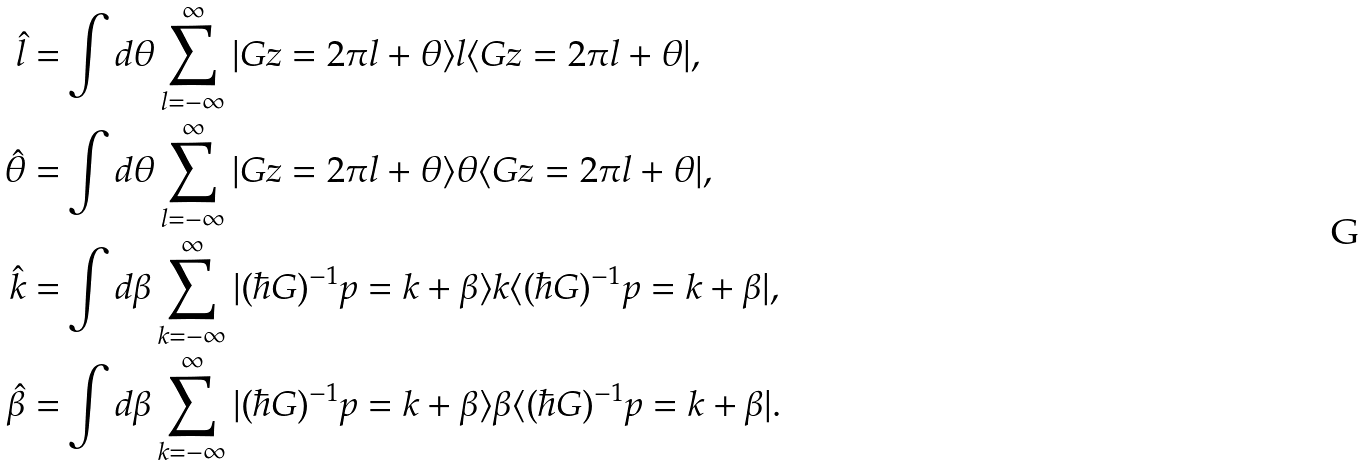Convert formula to latex. <formula><loc_0><loc_0><loc_500><loc_500>\hat { l } = & \int d \theta \sum _ { l = - \infty } ^ { \infty } | G z = 2 \pi l + \theta \rangle l \langle G z = 2 \pi l + \theta | , \\ \hat { \theta } = & \int d \theta \sum _ { l = - \infty } ^ { \infty } | G z = 2 \pi l + \theta \rangle \theta \langle G z = 2 \pi l + \theta | , \\ \hat { k } = & \int d \beta \sum _ { k = - \infty } ^ { \infty } | ( \hbar { G } ) ^ { - 1 } p = k + \beta \rangle k \langle ( \hbar { G } ) ^ { - 1 } p = k + \beta | , \\ \hat { \beta } = & \int d \beta \sum _ { k = - \infty } ^ { \infty } | ( \hbar { G } ) ^ { - 1 } p = k + \beta \rangle \beta \langle ( \hbar { G } ) ^ { - 1 } p = k + \beta | .</formula> 